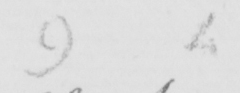What text is written in this handwritten line? 9 4 